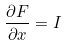<formula> <loc_0><loc_0><loc_500><loc_500>\frac { \partial F } { \partial x } = I</formula> 